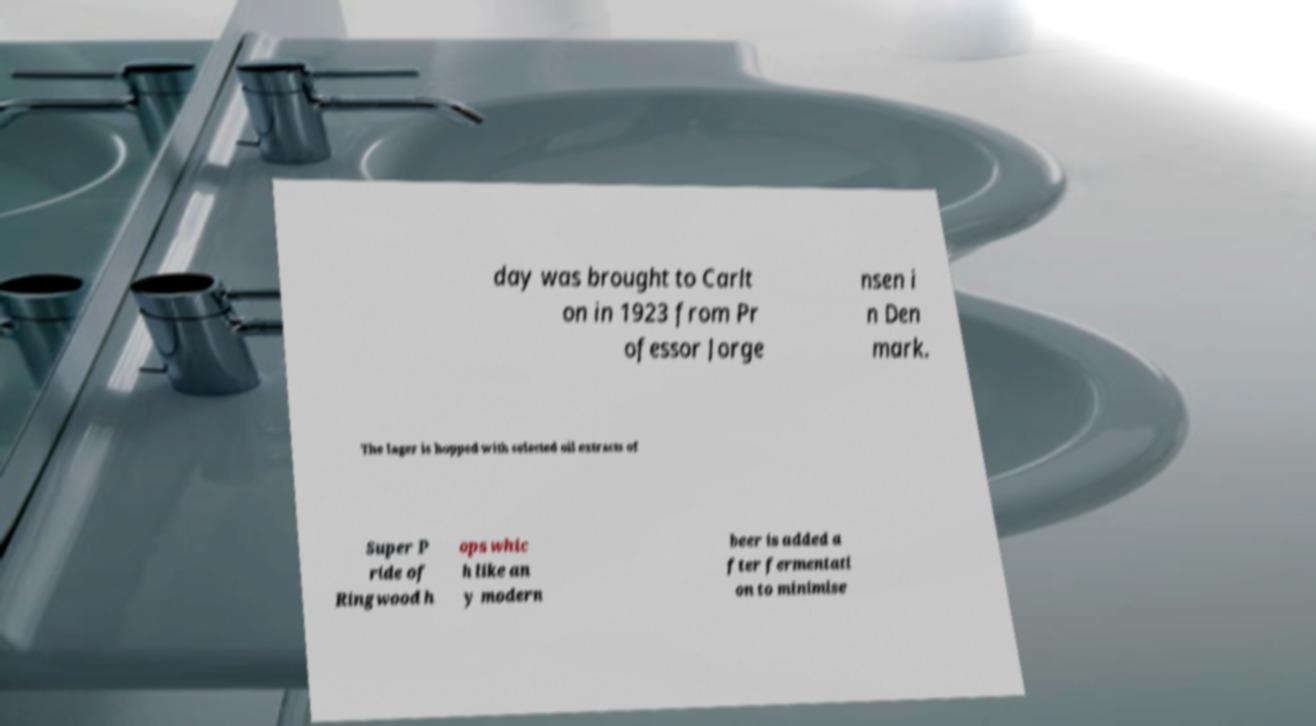Could you extract and type out the text from this image? day was brought to Carlt on in 1923 from Pr ofessor Jorge nsen i n Den mark. The lager is hopped with selected oil extracts of Super P ride of Ringwood h ops whic h like an y modern beer is added a fter fermentati on to minimise 